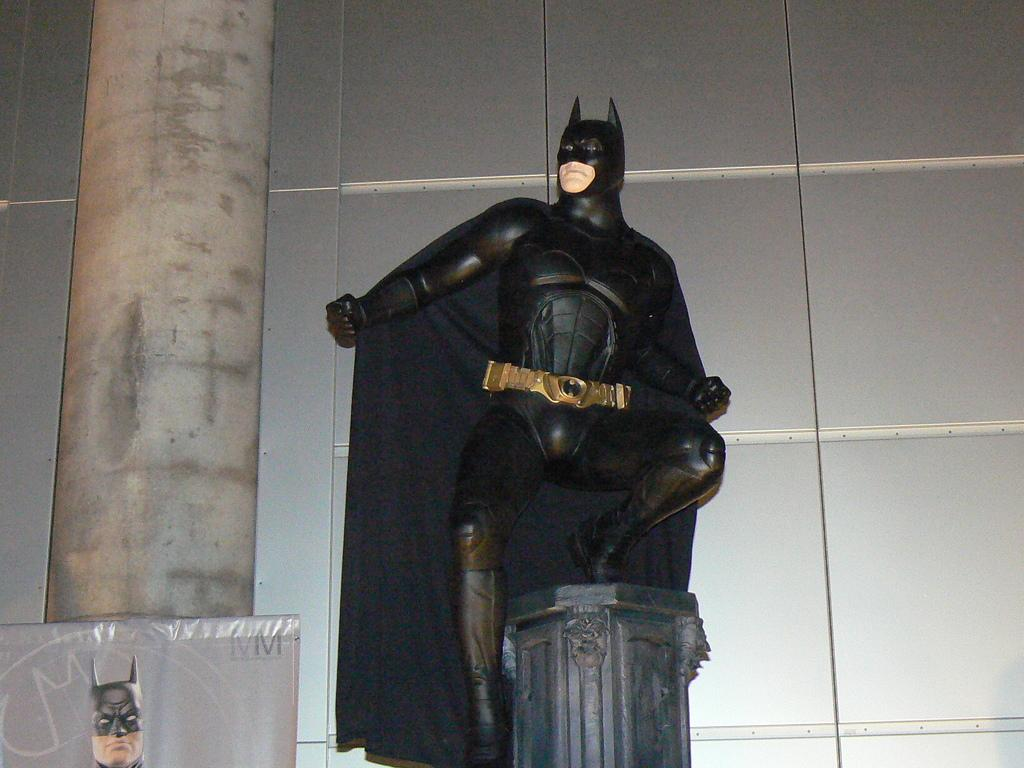What is the main subject of the image? The main subject of the image is a statue on a pillar. Are there any other structures or objects connected to the pillar? Yes, there is a board connecting two pillars in the image. What can be seen in the background of the image? There is a wall in the background of the image. What type of hair can be seen on the duck in the image? There is no duck present in the image, and therefore no hair can be observed. How is the string used in the image? There is no string present in the image. 